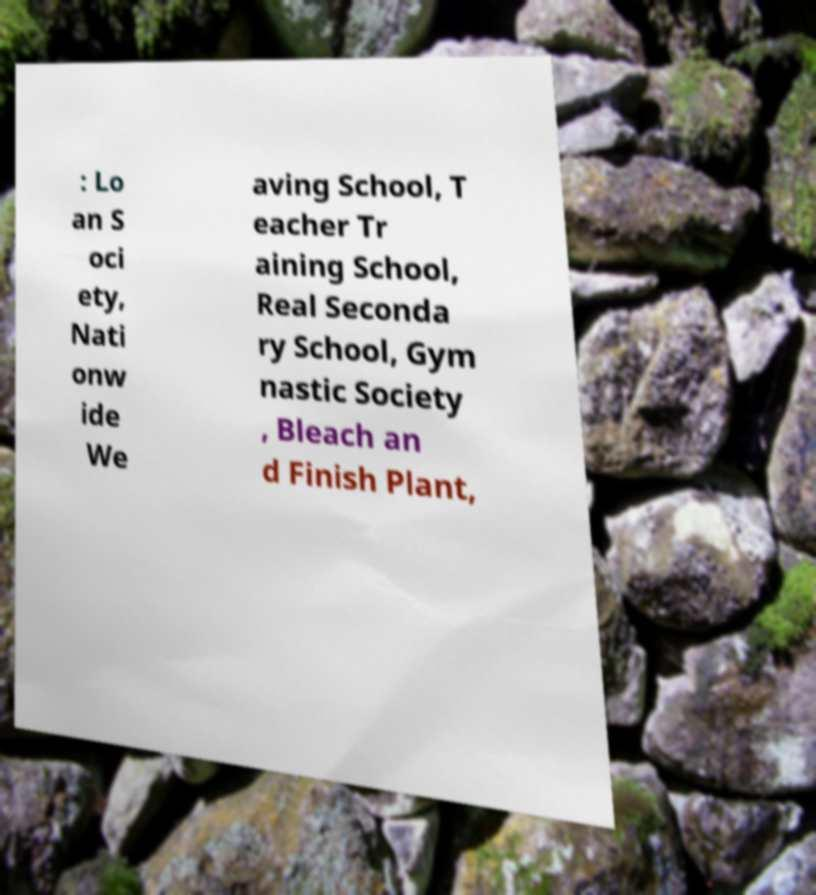There's text embedded in this image that I need extracted. Can you transcribe it verbatim? : Lo an S oci ety, Nati onw ide We aving School, T eacher Tr aining School, Real Seconda ry School, Gym nastic Society , Bleach an d Finish Plant, 